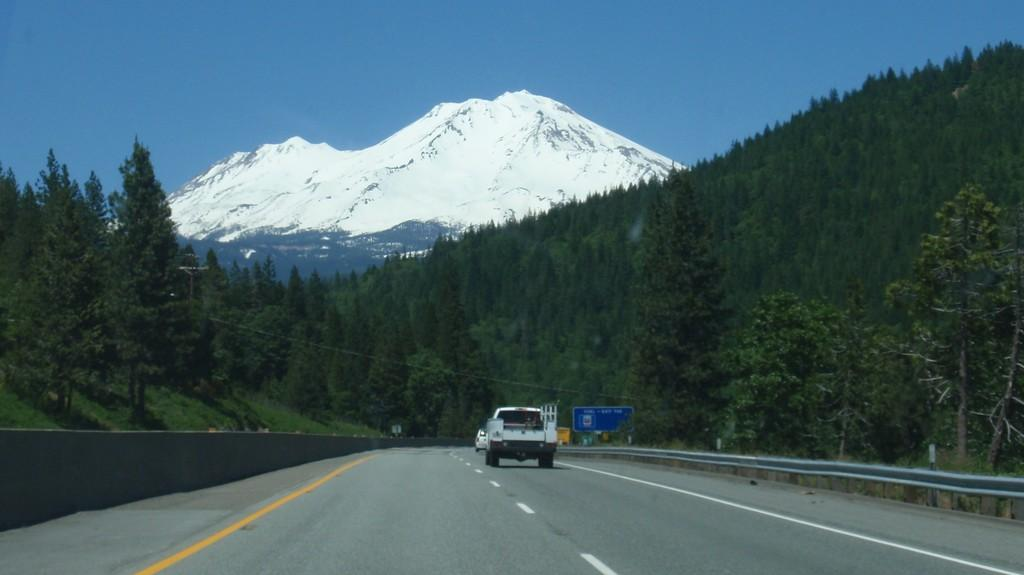What types of objects can be seen in the image in the image? There are vehicles, trees, and a board with text in the image. What is the landscape like in the image? The image features mountains and a road. What is visible in the sky in the image? The sky is visible in the image. Can you see any veins in the image? There are no veins present in the image. Is there a basketball game happening in the image? There is no basketball game or any reference to basketball in the image. 